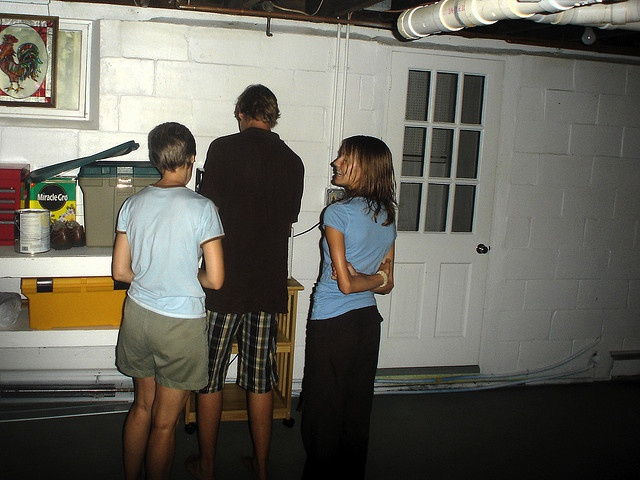Describe the objects in this image and their specific colors. I can see people in darkgray, gray, lightblue, and black tones, people in darkgray, black, maroon, and gray tones, and people in darkgray, black, and gray tones in this image. 